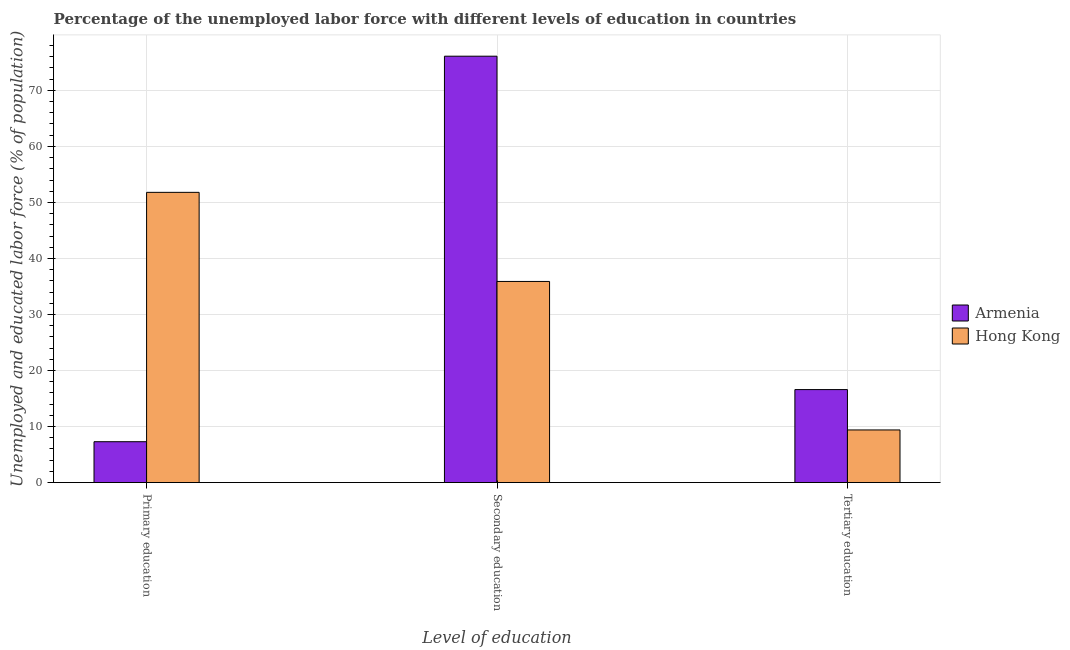How many groups of bars are there?
Your answer should be very brief. 3. Are the number of bars on each tick of the X-axis equal?
Your response must be concise. Yes. How many bars are there on the 2nd tick from the left?
Provide a short and direct response. 2. How many bars are there on the 3rd tick from the right?
Your response must be concise. 2. What is the label of the 2nd group of bars from the left?
Make the answer very short. Secondary education. What is the percentage of labor force who received primary education in Armenia?
Give a very brief answer. 7.3. Across all countries, what is the maximum percentage of labor force who received primary education?
Offer a very short reply. 51.8. Across all countries, what is the minimum percentage of labor force who received secondary education?
Your response must be concise. 35.9. In which country was the percentage of labor force who received primary education maximum?
Keep it short and to the point. Hong Kong. In which country was the percentage of labor force who received secondary education minimum?
Your answer should be compact. Hong Kong. What is the total percentage of labor force who received secondary education in the graph?
Your answer should be very brief. 112. What is the difference between the percentage of labor force who received secondary education in Hong Kong and that in Armenia?
Offer a terse response. -40.2. What is the difference between the percentage of labor force who received secondary education in Armenia and the percentage of labor force who received tertiary education in Hong Kong?
Keep it short and to the point. 66.7. What is the average percentage of labor force who received tertiary education per country?
Keep it short and to the point. 13. What is the difference between the percentage of labor force who received secondary education and percentage of labor force who received primary education in Armenia?
Your answer should be compact. 68.8. In how many countries, is the percentage of labor force who received tertiary education greater than 28 %?
Keep it short and to the point. 0. What is the ratio of the percentage of labor force who received primary education in Armenia to that in Hong Kong?
Make the answer very short. 0.14. Is the percentage of labor force who received tertiary education in Hong Kong less than that in Armenia?
Give a very brief answer. Yes. Is the difference between the percentage of labor force who received secondary education in Armenia and Hong Kong greater than the difference between the percentage of labor force who received primary education in Armenia and Hong Kong?
Give a very brief answer. Yes. What is the difference between the highest and the second highest percentage of labor force who received secondary education?
Provide a succinct answer. 40.2. What is the difference between the highest and the lowest percentage of labor force who received secondary education?
Your response must be concise. 40.2. In how many countries, is the percentage of labor force who received tertiary education greater than the average percentage of labor force who received tertiary education taken over all countries?
Keep it short and to the point. 1. What does the 1st bar from the left in Secondary education represents?
Ensure brevity in your answer.  Armenia. What does the 1st bar from the right in Secondary education represents?
Offer a terse response. Hong Kong. How many bars are there?
Offer a very short reply. 6. Are all the bars in the graph horizontal?
Provide a short and direct response. No. How many countries are there in the graph?
Offer a terse response. 2. How are the legend labels stacked?
Your response must be concise. Vertical. What is the title of the graph?
Your answer should be compact. Percentage of the unemployed labor force with different levels of education in countries. Does "Sao Tome and Principe" appear as one of the legend labels in the graph?
Provide a succinct answer. No. What is the label or title of the X-axis?
Ensure brevity in your answer.  Level of education. What is the label or title of the Y-axis?
Your answer should be very brief. Unemployed and educated labor force (% of population). What is the Unemployed and educated labor force (% of population) of Armenia in Primary education?
Give a very brief answer. 7.3. What is the Unemployed and educated labor force (% of population) of Hong Kong in Primary education?
Offer a very short reply. 51.8. What is the Unemployed and educated labor force (% of population) of Armenia in Secondary education?
Your answer should be very brief. 76.1. What is the Unemployed and educated labor force (% of population) of Hong Kong in Secondary education?
Ensure brevity in your answer.  35.9. What is the Unemployed and educated labor force (% of population) of Armenia in Tertiary education?
Your response must be concise. 16.6. What is the Unemployed and educated labor force (% of population) in Hong Kong in Tertiary education?
Offer a terse response. 9.4. Across all Level of education, what is the maximum Unemployed and educated labor force (% of population) in Armenia?
Offer a very short reply. 76.1. Across all Level of education, what is the maximum Unemployed and educated labor force (% of population) in Hong Kong?
Provide a short and direct response. 51.8. Across all Level of education, what is the minimum Unemployed and educated labor force (% of population) of Armenia?
Your answer should be very brief. 7.3. Across all Level of education, what is the minimum Unemployed and educated labor force (% of population) of Hong Kong?
Offer a terse response. 9.4. What is the total Unemployed and educated labor force (% of population) in Hong Kong in the graph?
Your answer should be compact. 97.1. What is the difference between the Unemployed and educated labor force (% of population) of Armenia in Primary education and that in Secondary education?
Keep it short and to the point. -68.8. What is the difference between the Unemployed and educated labor force (% of population) in Hong Kong in Primary education and that in Secondary education?
Provide a short and direct response. 15.9. What is the difference between the Unemployed and educated labor force (% of population) in Hong Kong in Primary education and that in Tertiary education?
Keep it short and to the point. 42.4. What is the difference between the Unemployed and educated labor force (% of population) of Armenia in Secondary education and that in Tertiary education?
Your response must be concise. 59.5. What is the difference between the Unemployed and educated labor force (% of population) of Armenia in Primary education and the Unemployed and educated labor force (% of population) of Hong Kong in Secondary education?
Offer a terse response. -28.6. What is the difference between the Unemployed and educated labor force (% of population) in Armenia in Secondary education and the Unemployed and educated labor force (% of population) in Hong Kong in Tertiary education?
Offer a very short reply. 66.7. What is the average Unemployed and educated labor force (% of population) in Armenia per Level of education?
Your response must be concise. 33.33. What is the average Unemployed and educated labor force (% of population) of Hong Kong per Level of education?
Offer a terse response. 32.37. What is the difference between the Unemployed and educated labor force (% of population) of Armenia and Unemployed and educated labor force (% of population) of Hong Kong in Primary education?
Make the answer very short. -44.5. What is the difference between the Unemployed and educated labor force (% of population) in Armenia and Unemployed and educated labor force (% of population) in Hong Kong in Secondary education?
Your answer should be very brief. 40.2. What is the difference between the Unemployed and educated labor force (% of population) in Armenia and Unemployed and educated labor force (% of population) in Hong Kong in Tertiary education?
Provide a succinct answer. 7.2. What is the ratio of the Unemployed and educated labor force (% of population) of Armenia in Primary education to that in Secondary education?
Keep it short and to the point. 0.1. What is the ratio of the Unemployed and educated labor force (% of population) in Hong Kong in Primary education to that in Secondary education?
Your response must be concise. 1.44. What is the ratio of the Unemployed and educated labor force (% of population) in Armenia in Primary education to that in Tertiary education?
Ensure brevity in your answer.  0.44. What is the ratio of the Unemployed and educated labor force (% of population) of Hong Kong in Primary education to that in Tertiary education?
Your response must be concise. 5.51. What is the ratio of the Unemployed and educated labor force (% of population) of Armenia in Secondary education to that in Tertiary education?
Provide a succinct answer. 4.58. What is the ratio of the Unemployed and educated labor force (% of population) of Hong Kong in Secondary education to that in Tertiary education?
Your response must be concise. 3.82. What is the difference between the highest and the second highest Unemployed and educated labor force (% of population) of Armenia?
Your response must be concise. 59.5. What is the difference between the highest and the lowest Unemployed and educated labor force (% of population) of Armenia?
Offer a terse response. 68.8. What is the difference between the highest and the lowest Unemployed and educated labor force (% of population) of Hong Kong?
Your answer should be very brief. 42.4. 